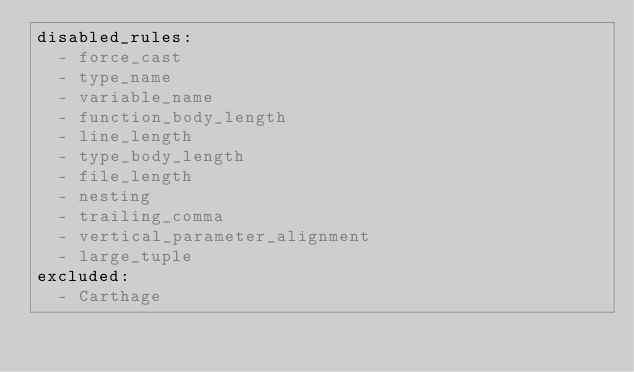<code> <loc_0><loc_0><loc_500><loc_500><_YAML_>disabled_rules:
  - force_cast
  - type_name
  - variable_name
  - function_body_length
  - line_length
  - type_body_length
  - file_length
  - nesting
  - trailing_comma
  - vertical_parameter_alignment
  - large_tuple
excluded:
  - Carthage
</code> 